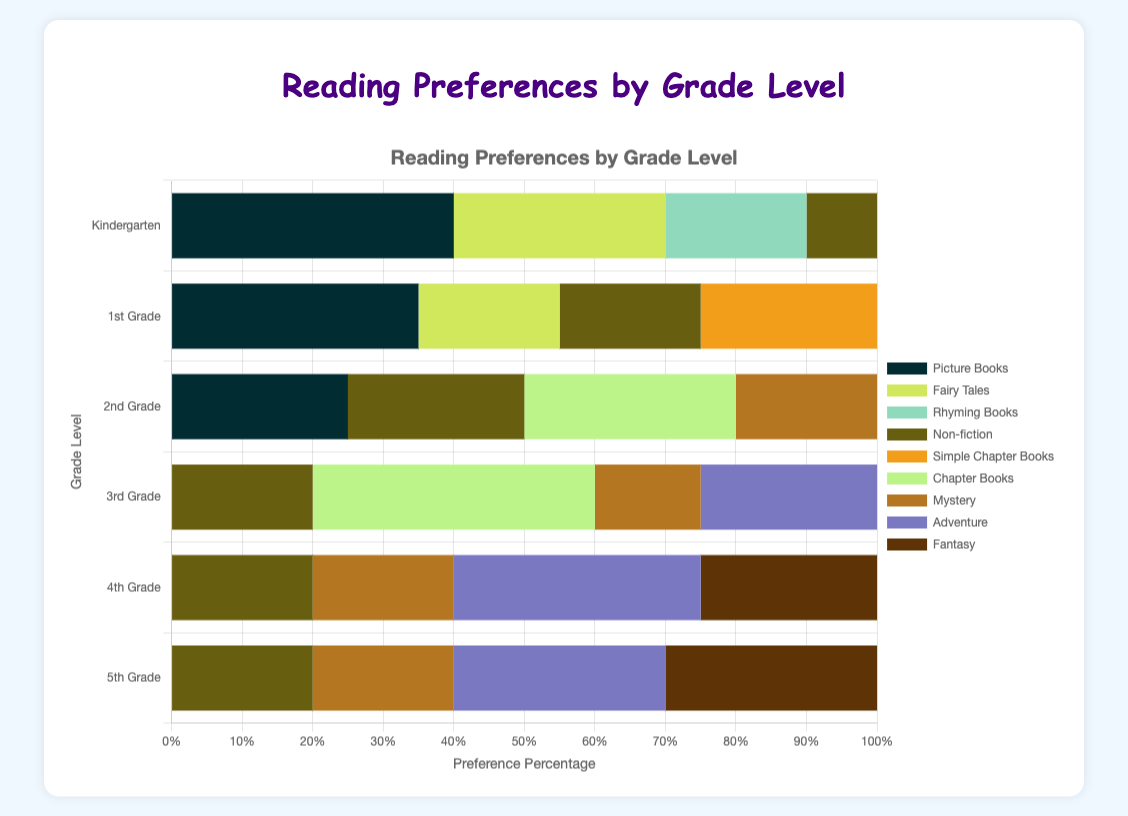What genre is the most preferred by Kindergarten students? Looking at the Kindergarten bar, the longest segment is for "Picture Books" with a preference percentage of 40%.
Answer: Picture Books Which grade level has the highest preference for "Adventure" books? By examining the length of the "Adventure" segments across all grade levels, the longest segment appears in the 4th grade with a preference percentage of 35%.
Answer: 4th Grade What is the total preference percentage for "Non-fiction" across all grade levels? Add the preference percentages for "Non-fiction" from all grade levels: 10% (Kindergarten) + 20% (1st Grade) + 25% (2nd Grade) + 20% (3rd Grade) + 20% (4th Grade) + 20% (5th Grade) = 115%.
Answer: 115% Which genre is equally preferred by both 1st Grade and 2nd Grade students? The "Non-fiction" genre has an equal preference percentage of 20% for both 1st Grade and 2nd Grade students according to the chart.
Answer: Non-fiction Is "Rhyming Books" a genre preferred by 3rd Grade students? By looking at the bars segmented by genre for the 3rd Grade, "Rhyming Books" is not displayed, indicating it is not among the preferred options.
Answer: No How does the preference for "Picture Books" change from Kindergarten to 2nd Grade? "Picture Books" preference starts at 40% in Kindergarten, decreases to 35% in 1st Grade, and further decreases to 25% in 2nd Grade. The change is -5% then -10%.
Answer: Decreases Which grade level has the highest preference for "Chapter Books"? "Chapter Books" preference is highest in 3rd Grade with a value of 40%, compared to other grades such as 2nd Grade (30%).
Answer: 3rd Grade How does the preference for "Fairy Tales" in 1st Grade compare to Kindergarten? In Kindergarten, the preference for "Fairy Tales" is 30%, while in 1st Grade it drops to 20%. The preference is 10 percentage points lower in 1st Grade.
Answer: Lower What is the combined preference percentage for "Fantasy" and "Adventure" books in 5th Grade? Add the preference percentages of "Fantasy" (30%) and "Adventure" (30%) for 5th Grade: 30% + 30% = 60%.
Answer: 60% Which grade level has the smallest preference for "Mystery" books and how much is it? By examining all the grade levels, the smallest preference for "Mystery" is in 3rd Grade with 15%.
Answer: 3rd Grade, 15% 